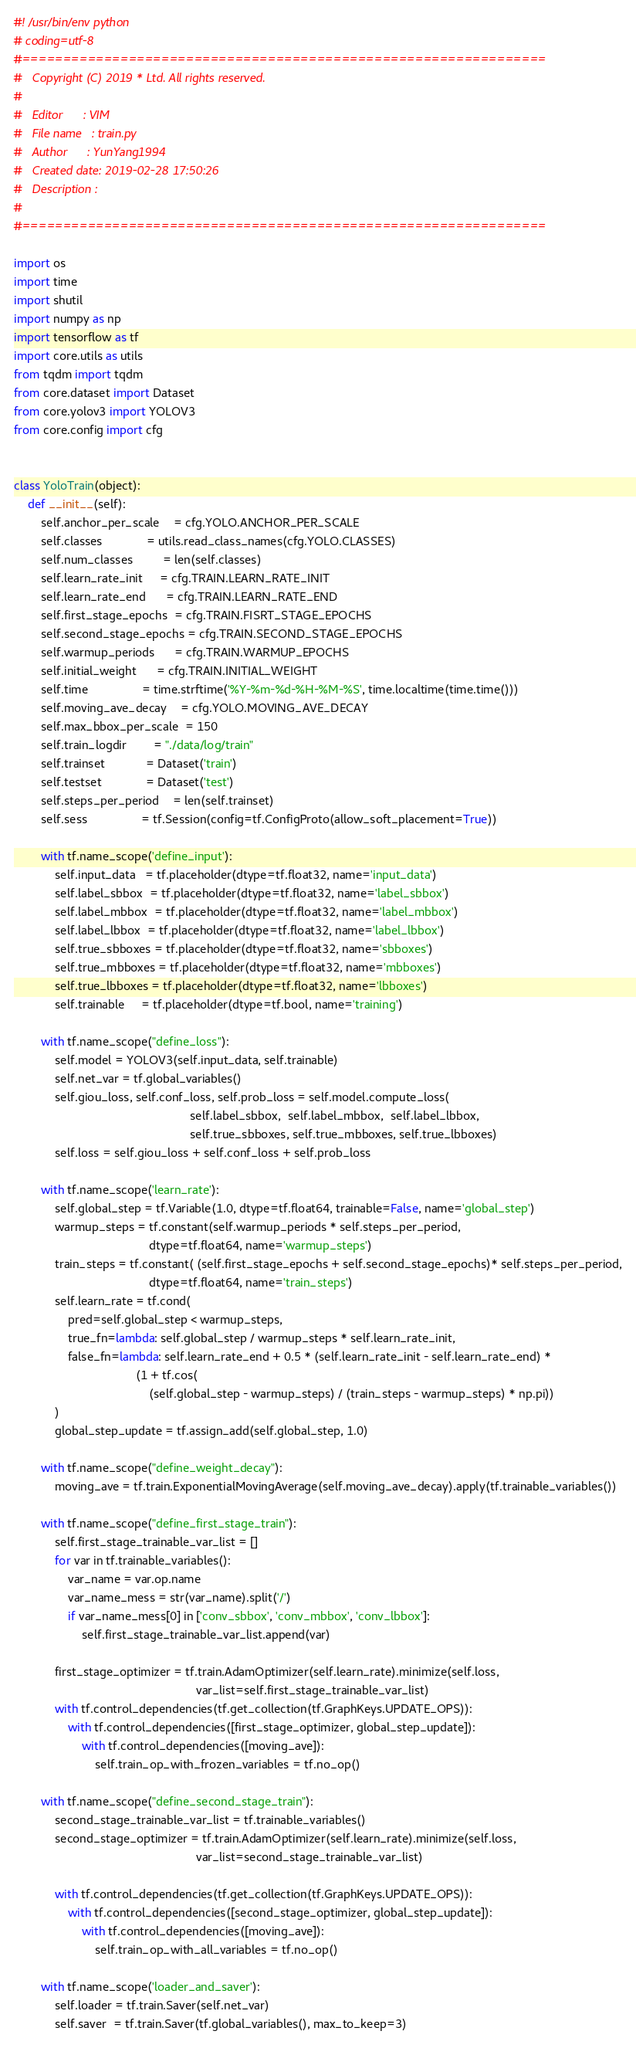<code> <loc_0><loc_0><loc_500><loc_500><_Python_>#! /usr/bin/env python
# coding=utf-8
#================================================================
#   Copyright (C) 2019 * Ltd. All rights reserved.
#
#   Editor      : VIM
#   File name   : train.py
#   Author      : YunYang1994
#   Created date: 2019-02-28 17:50:26
#   Description :
#
#================================================================

import os
import time
import shutil
import numpy as np
import tensorflow as tf
import core.utils as utils
from tqdm import tqdm
from core.dataset import Dataset
from core.yolov3 import YOLOV3
from core.config import cfg


class YoloTrain(object):
    def __init__(self):
        self.anchor_per_scale    = cfg.YOLO.ANCHOR_PER_SCALE
        self.classes             = utils.read_class_names(cfg.YOLO.CLASSES)
        self.num_classes         = len(self.classes)
        self.learn_rate_init     = cfg.TRAIN.LEARN_RATE_INIT
        self.learn_rate_end      = cfg.TRAIN.LEARN_RATE_END
        self.first_stage_epochs  = cfg.TRAIN.FISRT_STAGE_EPOCHS
        self.second_stage_epochs = cfg.TRAIN.SECOND_STAGE_EPOCHS
        self.warmup_periods      = cfg.TRAIN.WARMUP_EPOCHS
        self.initial_weight      = cfg.TRAIN.INITIAL_WEIGHT
        self.time                = time.strftime('%Y-%m-%d-%H-%M-%S', time.localtime(time.time()))
        self.moving_ave_decay    = cfg.YOLO.MOVING_AVE_DECAY
        self.max_bbox_per_scale  = 150
        self.train_logdir        = "./data/log/train"
        self.trainset            = Dataset('train')
        self.testset             = Dataset('test')
        self.steps_per_period    = len(self.trainset)
        self.sess                = tf.Session(config=tf.ConfigProto(allow_soft_placement=True))

        with tf.name_scope('define_input'):
            self.input_data   = tf.placeholder(dtype=tf.float32, name='input_data')
            self.label_sbbox  = tf.placeholder(dtype=tf.float32, name='label_sbbox')
            self.label_mbbox  = tf.placeholder(dtype=tf.float32, name='label_mbbox')
            self.label_lbbox  = tf.placeholder(dtype=tf.float32, name='label_lbbox')
            self.true_sbboxes = tf.placeholder(dtype=tf.float32, name='sbboxes')
            self.true_mbboxes = tf.placeholder(dtype=tf.float32, name='mbboxes')
            self.true_lbboxes = tf.placeholder(dtype=tf.float32, name='lbboxes')
            self.trainable     = tf.placeholder(dtype=tf.bool, name='training')

        with tf.name_scope("define_loss"):
            self.model = YOLOV3(self.input_data, self.trainable)
            self.net_var = tf.global_variables()
            self.giou_loss, self.conf_loss, self.prob_loss = self.model.compute_loss(
                                                    self.label_sbbox,  self.label_mbbox,  self.label_lbbox,
                                                    self.true_sbboxes, self.true_mbboxes, self.true_lbboxes)
            self.loss = self.giou_loss + self.conf_loss + self.prob_loss

        with tf.name_scope('learn_rate'):
            self.global_step = tf.Variable(1.0, dtype=tf.float64, trainable=False, name='global_step')
            warmup_steps = tf.constant(self.warmup_periods * self.steps_per_period,
                                        dtype=tf.float64, name='warmup_steps')
            train_steps = tf.constant( (self.first_stage_epochs + self.second_stage_epochs)* self.steps_per_period,
                                        dtype=tf.float64, name='train_steps')
            self.learn_rate = tf.cond(
                pred=self.global_step < warmup_steps,
                true_fn=lambda: self.global_step / warmup_steps * self.learn_rate_init,
                false_fn=lambda: self.learn_rate_end + 0.5 * (self.learn_rate_init - self.learn_rate_end) *
                                    (1 + tf.cos(
                                        (self.global_step - warmup_steps) / (train_steps - warmup_steps) * np.pi))
            )
            global_step_update = tf.assign_add(self.global_step, 1.0)

        with tf.name_scope("define_weight_decay"):
            moving_ave = tf.train.ExponentialMovingAverage(self.moving_ave_decay).apply(tf.trainable_variables())

        with tf.name_scope("define_first_stage_train"):
            self.first_stage_trainable_var_list = []
            for var in tf.trainable_variables():
                var_name = var.op.name
                var_name_mess = str(var_name).split('/')
                if var_name_mess[0] in ['conv_sbbox', 'conv_mbbox', 'conv_lbbox']:
                    self.first_stage_trainable_var_list.append(var)

            first_stage_optimizer = tf.train.AdamOptimizer(self.learn_rate).minimize(self.loss,
                                                      var_list=self.first_stage_trainable_var_list)
            with tf.control_dependencies(tf.get_collection(tf.GraphKeys.UPDATE_OPS)):
                with tf.control_dependencies([first_stage_optimizer, global_step_update]):
                    with tf.control_dependencies([moving_ave]):
                        self.train_op_with_frozen_variables = tf.no_op()

        with tf.name_scope("define_second_stage_train"):
            second_stage_trainable_var_list = tf.trainable_variables()
            second_stage_optimizer = tf.train.AdamOptimizer(self.learn_rate).minimize(self.loss,
                                                      var_list=second_stage_trainable_var_list)

            with tf.control_dependencies(tf.get_collection(tf.GraphKeys.UPDATE_OPS)):
                with tf.control_dependencies([second_stage_optimizer, global_step_update]):
                    with tf.control_dependencies([moving_ave]):
                        self.train_op_with_all_variables = tf.no_op()

        with tf.name_scope('loader_and_saver'):
            self.loader = tf.train.Saver(self.net_var)
            self.saver  = tf.train.Saver(tf.global_variables(), max_to_keep=3)
</code> 